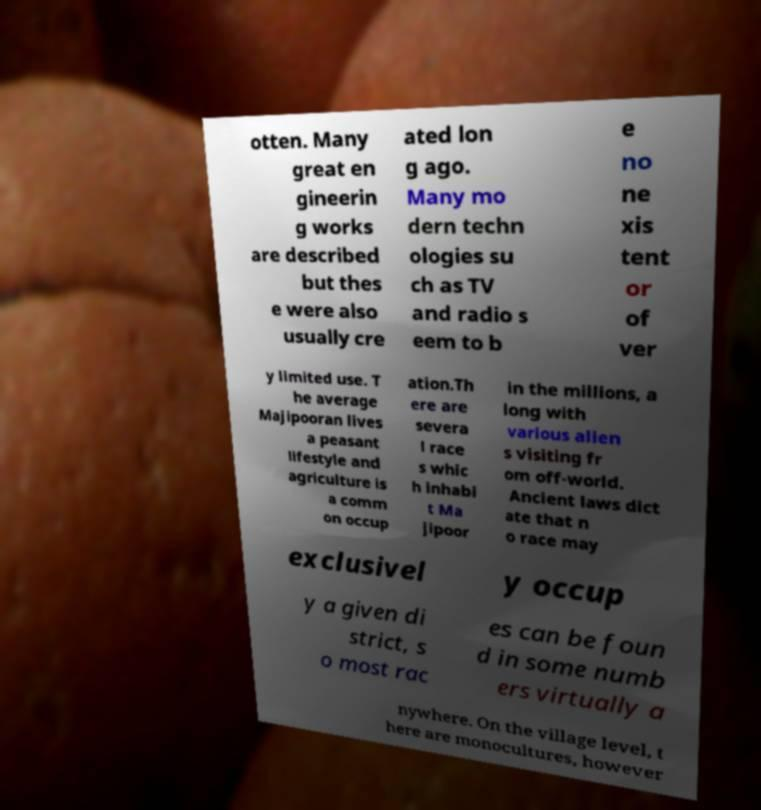Can you read and provide the text displayed in the image?This photo seems to have some interesting text. Can you extract and type it out for me? otten. Many great en gineerin g works are described but thes e were also usually cre ated lon g ago. Many mo dern techn ologies su ch as TV and radio s eem to b e no ne xis tent or of ver y limited use. T he average Majipooran lives a peasant lifestyle and agriculture is a comm on occup ation.Th ere are severa l race s whic h inhabi t Ma jipoor in the millions, a long with various alien s visiting fr om off-world. Ancient laws dict ate that n o race may exclusivel y occup y a given di strict, s o most rac es can be foun d in some numb ers virtually a nywhere. On the village level, t here are monocultures, however 